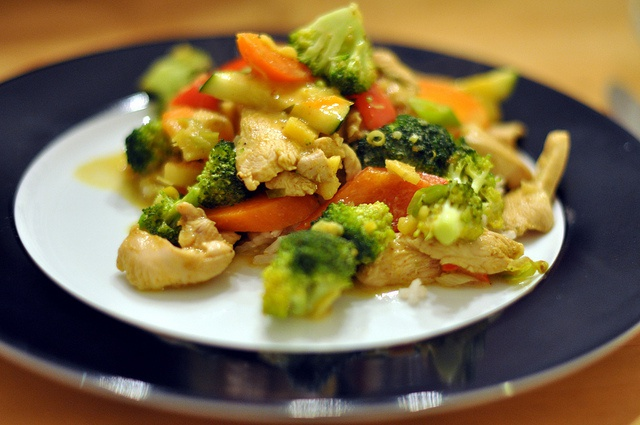Describe the objects in this image and their specific colors. I can see broccoli in maroon, olive, and black tones, broccoli in maroon, olive, and khaki tones, broccoli in maroon, black, darkgreen, and olive tones, broccoli in maroon, olive, and khaki tones, and broccoli in maroon, olive, black, and darkgreen tones in this image. 